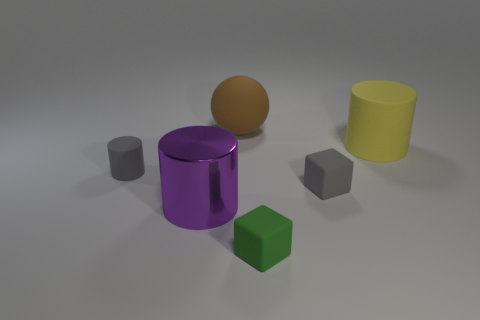Add 4 small objects. How many objects exist? 10 Subtract all cubes. How many objects are left? 4 Subtract 1 gray cylinders. How many objects are left? 5 Subtract all big red blocks. Subtract all small rubber things. How many objects are left? 3 Add 4 large brown objects. How many large brown objects are left? 5 Add 3 tiny red cubes. How many tiny red cubes exist? 3 